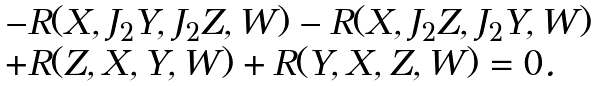<formula> <loc_0><loc_0><loc_500><loc_500>\begin{array} { l } - R ( X , J _ { 2 } Y , J _ { 2 } Z , W ) - R ( X , J _ { 2 } Z , J _ { 2 } Y , W ) \\ + R ( Z , X , Y , W ) + R ( Y , X , Z , W ) = 0 . \end{array}</formula> 